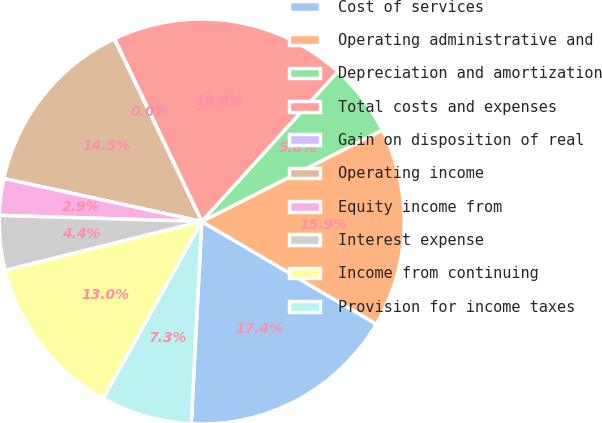Convert chart. <chart><loc_0><loc_0><loc_500><loc_500><pie_chart><fcel>Cost of services<fcel>Operating administrative and<fcel>Depreciation and amortization<fcel>Total costs and expenses<fcel>Gain on disposition of real<fcel>Operating income<fcel>Equity income from<fcel>Interest expense<fcel>Income from continuing<fcel>Provision for income taxes<nl><fcel>17.37%<fcel>15.92%<fcel>5.81%<fcel>18.81%<fcel>0.03%<fcel>14.48%<fcel>2.92%<fcel>4.37%<fcel>13.03%<fcel>7.26%<nl></chart> 